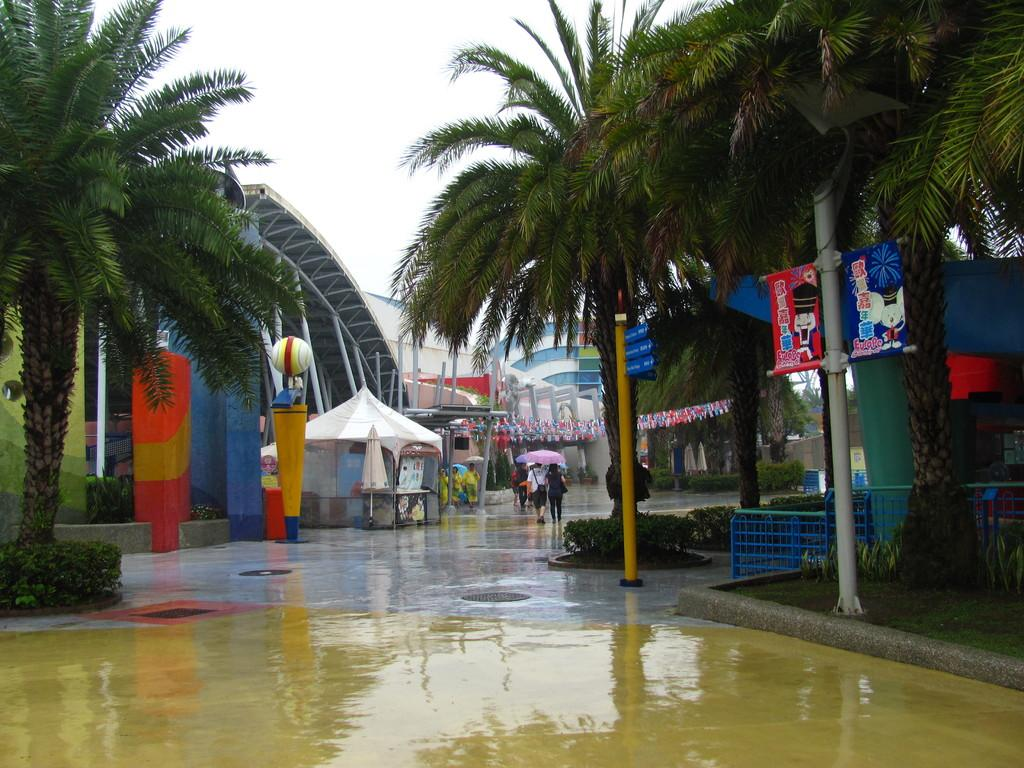What type of natural elements can be seen in the image? There are trees and plants in the image. What man-made structures are present in the image? There are poles, fences, buildings, and a tent in the image. What objects are attached to the poles? Banners are present on the poles. Can you describe the people in the image? There are persons in the image. What type of protection from the elements is visible in the image? An umbrella is visible in the image. What type of materials can be seen in the image? Metal objects are present in the image. What part of the natural environment is visible in the image? The sky is visible in the image. What type of boundary is being enforced by the army in the image? There is no army or boundary present in the image. How does the person in the image respond to the cough of another person? There is no cough or response to a cough in the image. 